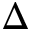Convert formula to latex. <formula><loc_0><loc_0><loc_500><loc_500>\Delta</formula> 